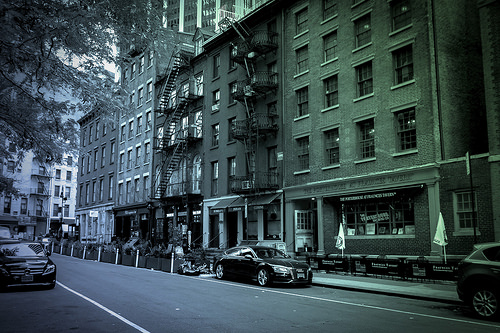<image>
Can you confirm if the car is in front of the car? No. The car is not in front of the car. The spatial positioning shows a different relationship between these objects. 